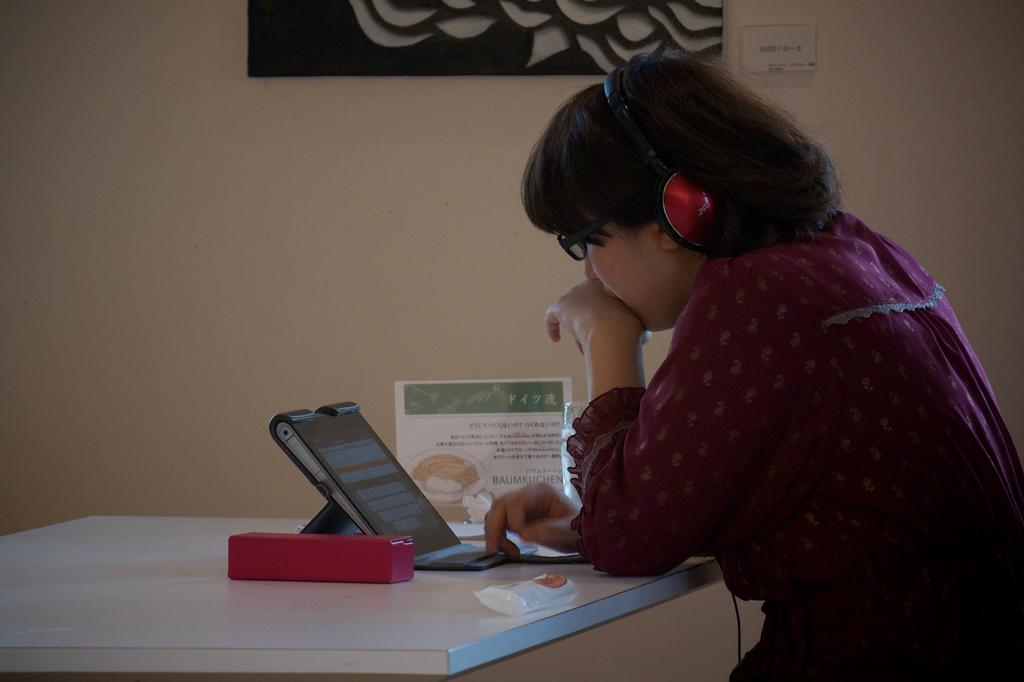What is the girl in the image doing? The girl is sitting in the image. What is in front of the girl? There is a table in front of the girl. What is on the table? There is a laptop on the table, and there are some objects on the table as well. What can be seen in the background of the image? There is a frame on the wall in the background. What type of creature is sitting next to the girl in the image? There is no creature sitting next to the girl in the image; only the girl, table, laptop, and objects on the table are present. 